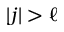Convert formula to latex. <formula><loc_0><loc_0><loc_500><loc_500>| j | > \ell</formula> 